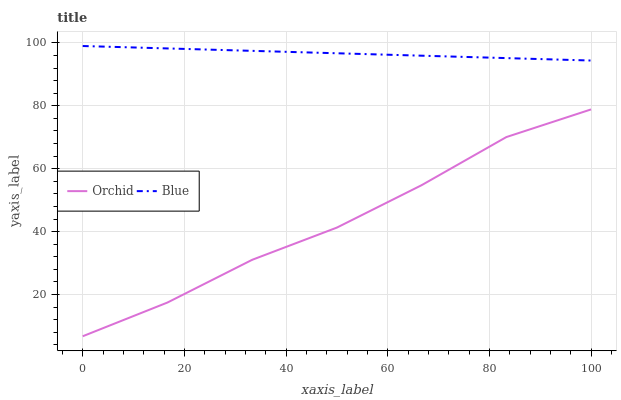Does Orchid have the minimum area under the curve?
Answer yes or no. Yes. Does Blue have the maximum area under the curve?
Answer yes or no. Yes. Does Orchid have the maximum area under the curve?
Answer yes or no. No. Is Blue the smoothest?
Answer yes or no. Yes. Is Orchid the roughest?
Answer yes or no. Yes. Is Orchid the smoothest?
Answer yes or no. No. Does Orchid have the lowest value?
Answer yes or no. Yes. Does Blue have the highest value?
Answer yes or no. Yes. Does Orchid have the highest value?
Answer yes or no. No. Is Orchid less than Blue?
Answer yes or no. Yes. Is Blue greater than Orchid?
Answer yes or no. Yes. Does Orchid intersect Blue?
Answer yes or no. No. 